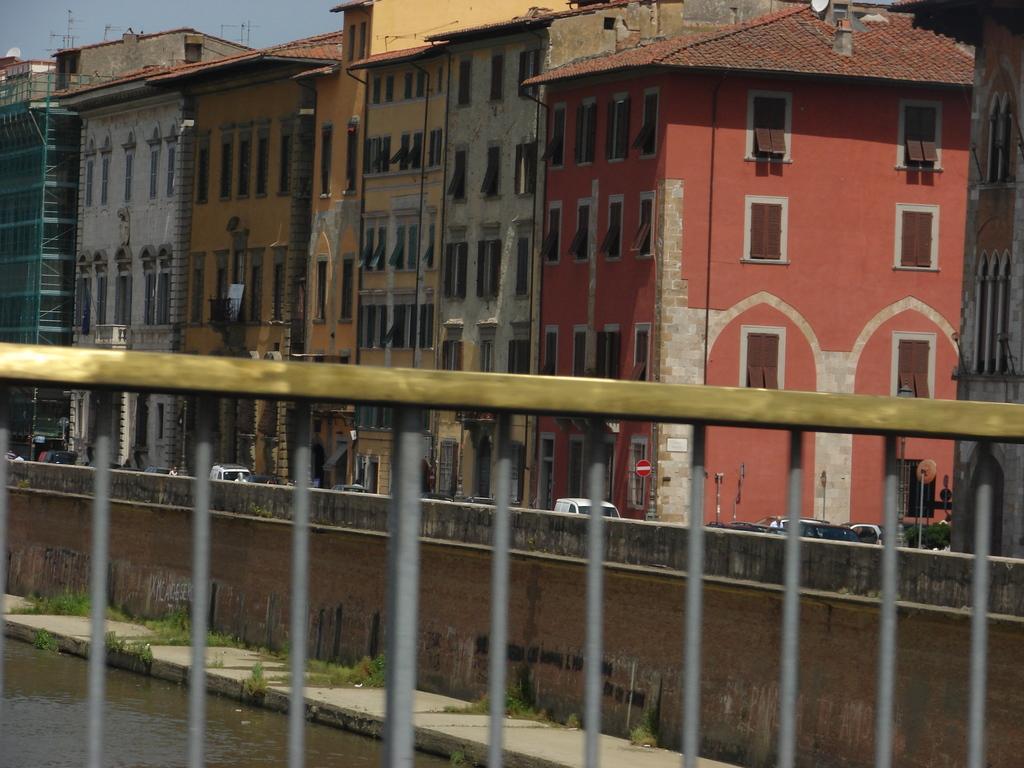In one or two sentences, can you explain what this image depicts? We can see fence, through this fence we can see water, grass and wall. In the background we can see buildings, vehicles, boards on poles and sky. 